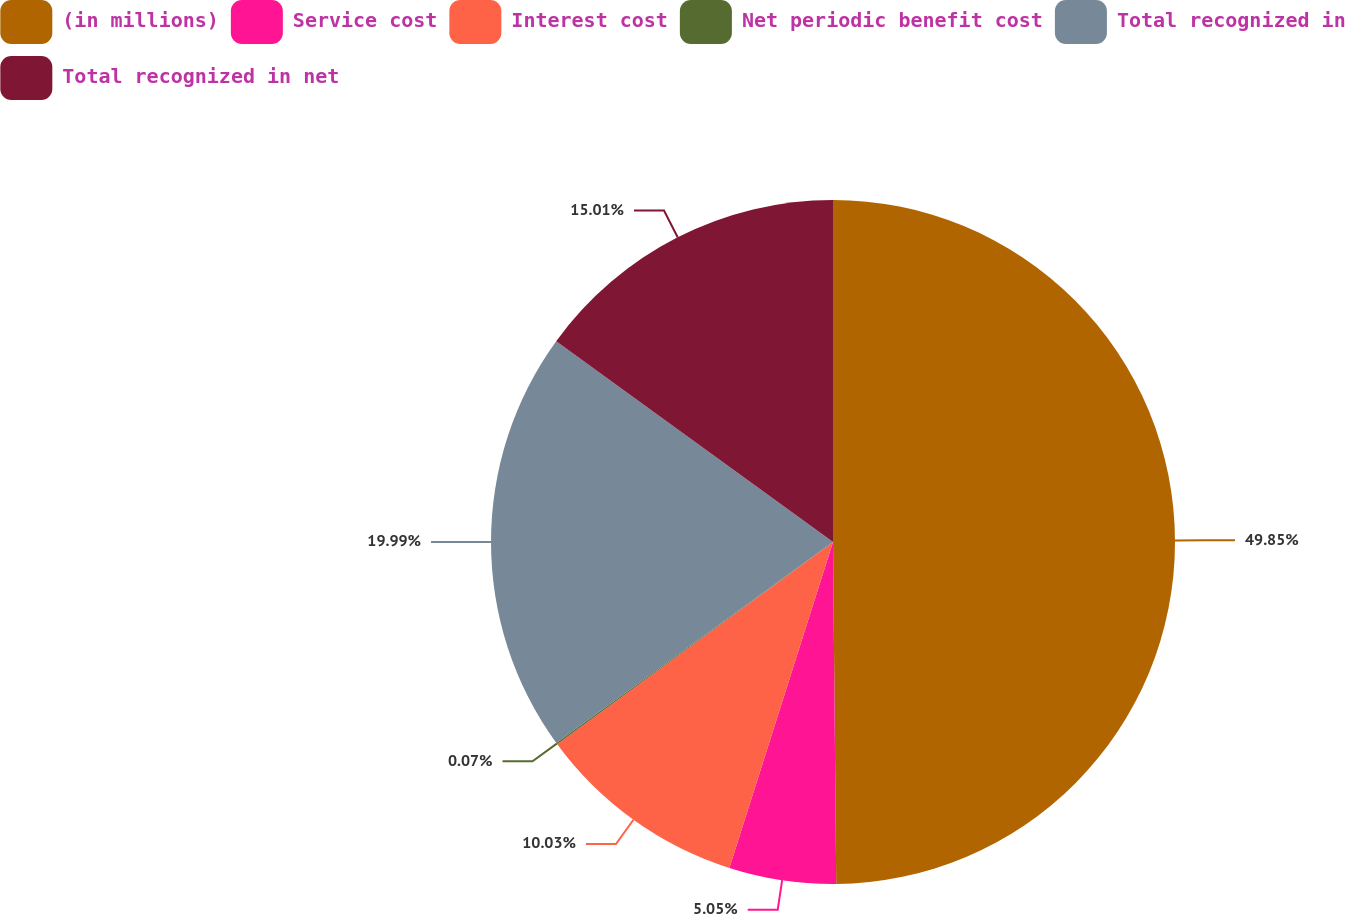Convert chart to OTSL. <chart><loc_0><loc_0><loc_500><loc_500><pie_chart><fcel>(in millions)<fcel>Service cost<fcel>Interest cost<fcel>Net periodic benefit cost<fcel>Total recognized in<fcel>Total recognized in net<nl><fcel>49.85%<fcel>5.05%<fcel>10.03%<fcel>0.07%<fcel>19.99%<fcel>15.01%<nl></chart> 